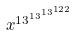Convert formula to latex. <formula><loc_0><loc_0><loc_500><loc_500>x ^ { 1 3 ^ { 1 3 ^ { 1 3 ^ { 1 2 2 } } } }</formula> 